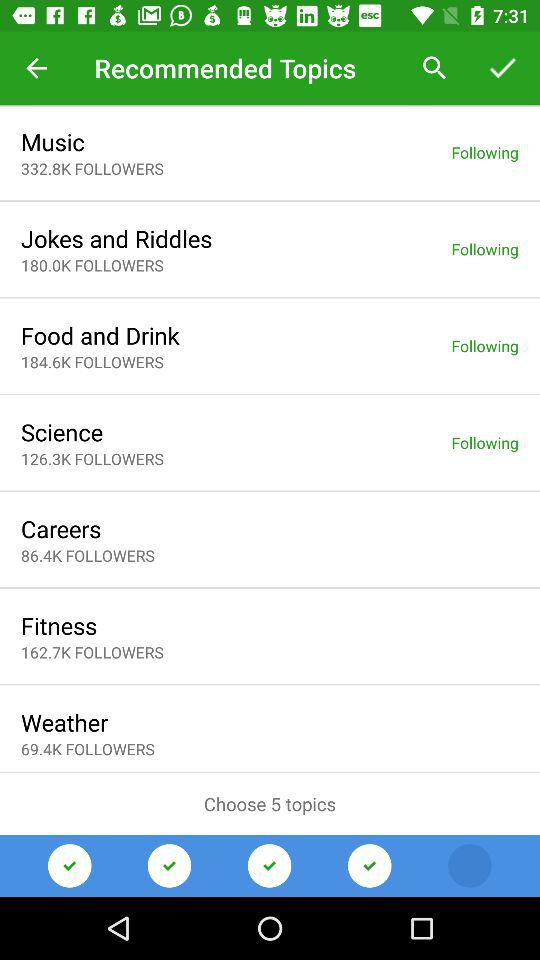How many topics do we need to choose? You need to choose 5 topics. 